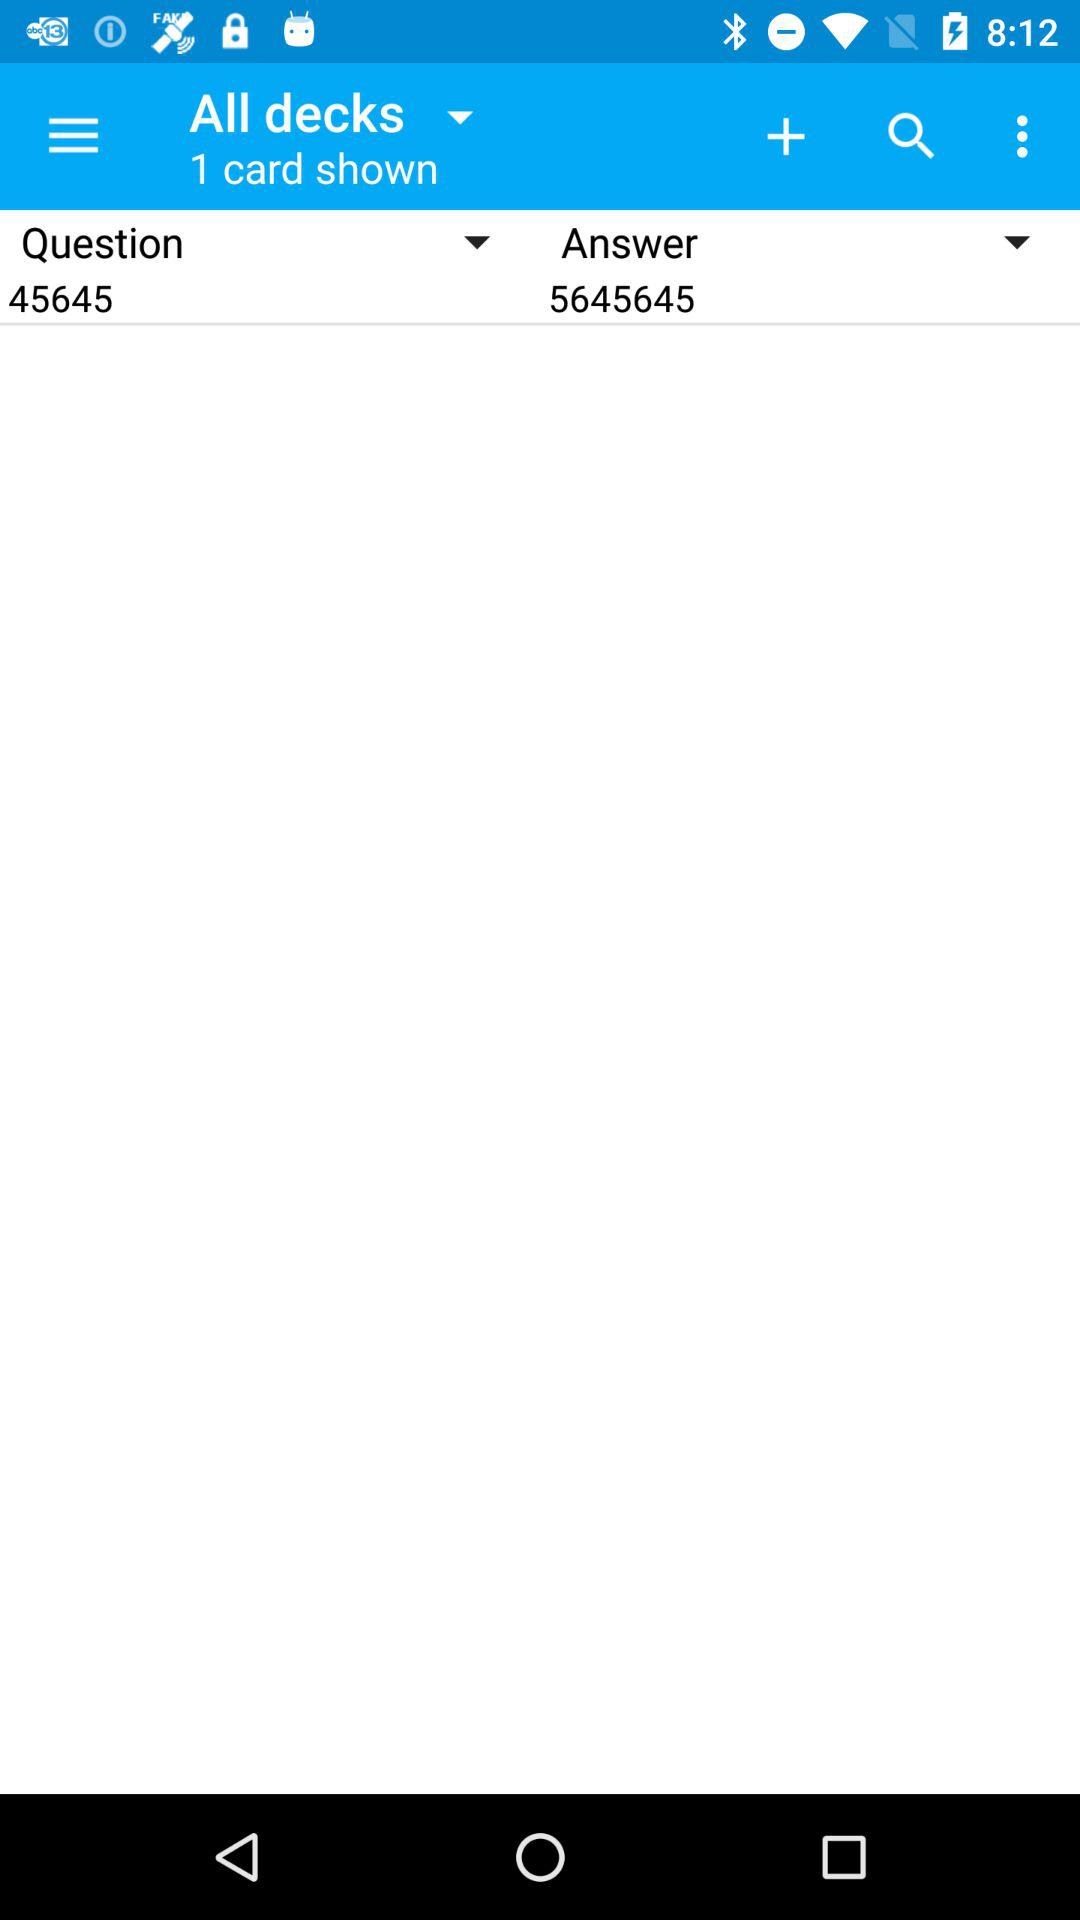What is the shown number of cards? The number of cards is 1. 